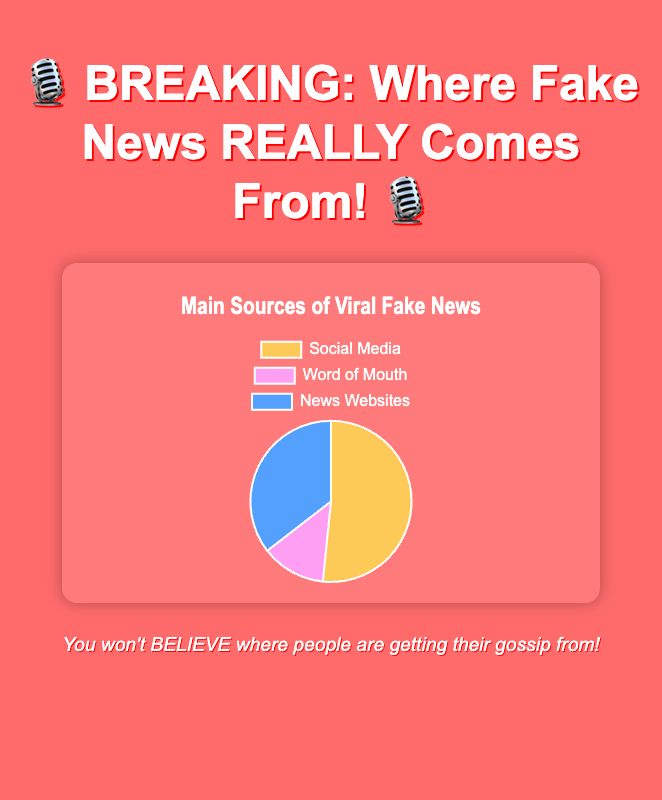Which main source of fake news has the largest percentage? The pie chart shows that Social Media has the largest segment, visually the biggest part of the pie, with 80%.
Answer: Social Media What is the combined percentage of fake news from Social Media and News Websites? From the pie chart, Social Media is 80% and News Websites is 55%. Adding these together: 80 + 55 = 135.
Answer: 135 Which source contributes the least to the spread of fake news? The pie chart shows that Word of Mouth has the smallest segment, visually the smallest part of the pie, with 20%.
Answer: Word of Mouth How does the percentage of fake news from Word of Mouth compare to News Websites? Word of Mouth is 20% and News Websites is 55%. Comparing these, 20 is less than 55.
Answer: Less than What is the percentage difference between fake news from Social Media and Word of Mouth? Social Media is 80% and Word of Mouth is 20%. The difference is: 80 - 20 = 60.
Answer: 60 If you sum the percentages of Word of Mouth and News Websites, do they surpass the percentage of Social Media? Word of Mouth is 20% and News Websites is 55%. Summing these: 20 + 55 = 75, which is less than Social Media's 80%.
Answer: No What proportion of the fake news comes from sources other than Social Media? Non-Social Media sources are Word of Mouth (20%) and News Websites (55%). Summing these: 20 + 55 = 75, so 75% comes from other sources.
Answer: 75 Is the visual size of the Word of Mouth segment larger than any other segment in the pie chart? In the chart, the smallest segment is Word of Mouth with 20%, which is smaller than Social Media (80%) and News Websites (55%).
Answer: No, it's the smallest What color is used to represent News Websites in the pie chart? The pie chart uses blue for News Websites.
Answer: Blue 